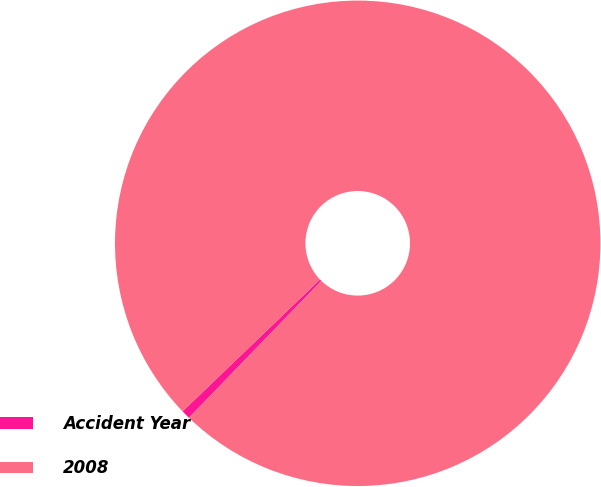<chart> <loc_0><loc_0><loc_500><loc_500><pie_chart><fcel>Accident Year<fcel>2008<nl><fcel>0.59%<fcel>99.41%<nl></chart> 